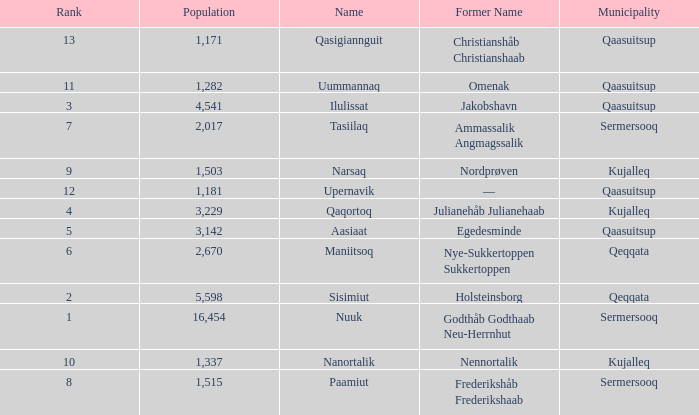Who has a former name of nordprøven? Narsaq. 